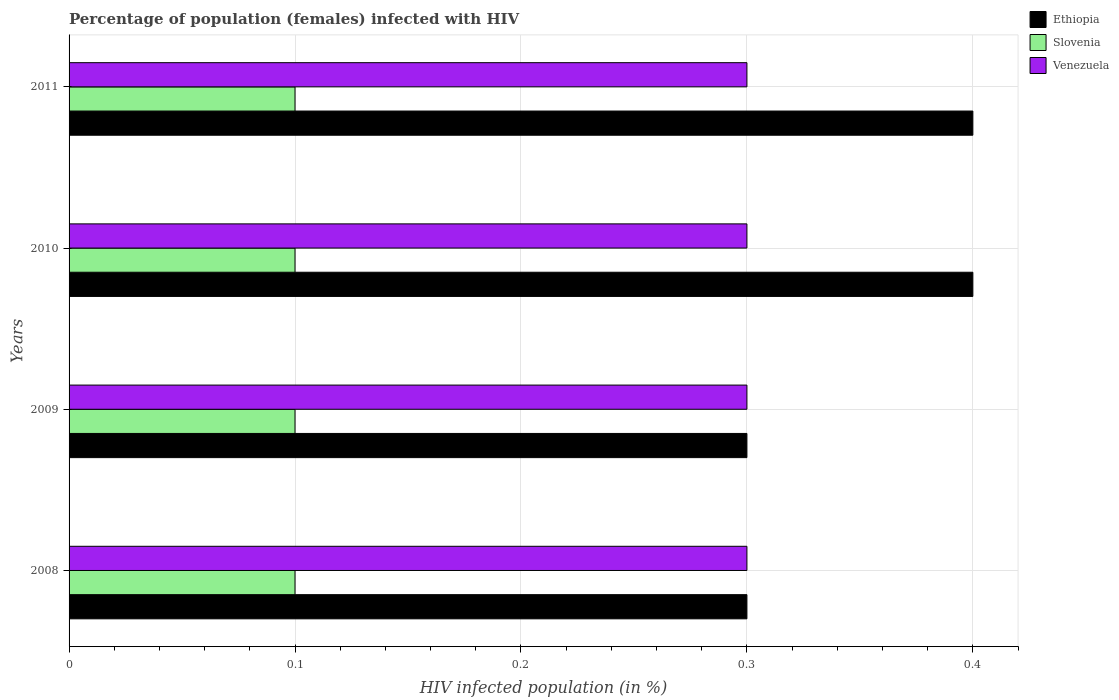How many different coloured bars are there?
Make the answer very short. 3. How many groups of bars are there?
Offer a terse response. 4. Are the number of bars on each tick of the Y-axis equal?
Provide a succinct answer. Yes. How many bars are there on the 1st tick from the bottom?
Your response must be concise. 3. In how many cases, is the number of bars for a given year not equal to the number of legend labels?
Offer a terse response. 0. What is the total percentage of HIV infected female population in Venezuela in the graph?
Offer a very short reply. 1.2. What is the difference between the percentage of HIV infected female population in Ethiopia in 2010 and the percentage of HIV infected female population in Venezuela in 2009?
Make the answer very short. 0.1. In the year 2011, what is the difference between the percentage of HIV infected female population in Ethiopia and percentage of HIV infected female population in Slovenia?
Offer a very short reply. 0.3. What is the difference between the highest and the second highest percentage of HIV infected female population in Venezuela?
Keep it short and to the point. 0. What is the difference between the highest and the lowest percentage of HIV infected female population in Slovenia?
Make the answer very short. 0. In how many years, is the percentage of HIV infected female population in Slovenia greater than the average percentage of HIV infected female population in Slovenia taken over all years?
Your answer should be compact. 0. What does the 3rd bar from the top in 2008 represents?
Your response must be concise. Ethiopia. What does the 2nd bar from the bottom in 2009 represents?
Ensure brevity in your answer.  Slovenia. Are the values on the major ticks of X-axis written in scientific E-notation?
Provide a short and direct response. No. Does the graph contain any zero values?
Give a very brief answer. No. Where does the legend appear in the graph?
Make the answer very short. Top right. How many legend labels are there?
Your answer should be compact. 3. How are the legend labels stacked?
Offer a terse response. Vertical. What is the title of the graph?
Provide a succinct answer. Percentage of population (females) infected with HIV. Does "United States" appear as one of the legend labels in the graph?
Your answer should be compact. No. What is the label or title of the X-axis?
Keep it short and to the point. HIV infected population (in %). What is the HIV infected population (in %) of Ethiopia in 2010?
Your answer should be compact. 0.4. What is the HIV infected population (in %) of Slovenia in 2011?
Make the answer very short. 0.1. Across all years, what is the maximum HIV infected population (in %) in Ethiopia?
Your answer should be compact. 0.4. Across all years, what is the maximum HIV infected population (in %) in Venezuela?
Make the answer very short. 0.3. Across all years, what is the minimum HIV infected population (in %) of Ethiopia?
Provide a short and direct response. 0.3. Across all years, what is the minimum HIV infected population (in %) of Slovenia?
Your answer should be very brief. 0.1. Across all years, what is the minimum HIV infected population (in %) in Venezuela?
Provide a succinct answer. 0.3. What is the total HIV infected population (in %) of Ethiopia in the graph?
Offer a very short reply. 1.4. What is the total HIV infected population (in %) in Slovenia in the graph?
Keep it short and to the point. 0.4. What is the difference between the HIV infected population (in %) of Venezuela in 2008 and that in 2009?
Provide a succinct answer. 0. What is the difference between the HIV infected population (in %) of Ethiopia in 2008 and that in 2010?
Your response must be concise. -0.1. What is the difference between the HIV infected population (in %) of Slovenia in 2008 and that in 2010?
Your answer should be compact. 0. What is the difference between the HIV infected population (in %) of Venezuela in 2008 and that in 2010?
Make the answer very short. 0. What is the difference between the HIV infected population (in %) of Ethiopia in 2008 and that in 2011?
Your answer should be compact. -0.1. What is the difference between the HIV infected population (in %) of Venezuela in 2008 and that in 2011?
Offer a very short reply. 0. What is the difference between the HIV infected population (in %) of Ethiopia in 2009 and that in 2010?
Give a very brief answer. -0.1. What is the difference between the HIV infected population (in %) in Slovenia in 2009 and that in 2010?
Your answer should be compact. 0. What is the difference between the HIV infected population (in %) of Venezuela in 2009 and that in 2010?
Your response must be concise. 0. What is the difference between the HIV infected population (in %) in Venezuela in 2009 and that in 2011?
Your response must be concise. 0. What is the difference between the HIV infected population (in %) in Venezuela in 2010 and that in 2011?
Give a very brief answer. 0. What is the difference between the HIV infected population (in %) of Ethiopia in 2008 and the HIV infected population (in %) of Slovenia in 2009?
Offer a terse response. 0.2. What is the difference between the HIV infected population (in %) of Ethiopia in 2008 and the HIV infected population (in %) of Venezuela in 2009?
Make the answer very short. 0. What is the difference between the HIV infected population (in %) of Slovenia in 2008 and the HIV infected population (in %) of Venezuela in 2009?
Make the answer very short. -0.2. What is the difference between the HIV infected population (in %) in Ethiopia in 2008 and the HIV infected population (in %) in Venezuela in 2010?
Offer a very short reply. 0. What is the difference between the HIV infected population (in %) in Ethiopia in 2008 and the HIV infected population (in %) in Venezuela in 2011?
Ensure brevity in your answer.  0. What is the difference between the HIV infected population (in %) in Ethiopia in 2009 and the HIV infected population (in %) in Slovenia in 2010?
Keep it short and to the point. 0.2. What is the difference between the HIV infected population (in %) of Slovenia in 2009 and the HIV infected population (in %) of Venezuela in 2010?
Your response must be concise. -0.2. What is the difference between the HIV infected population (in %) of Ethiopia in 2009 and the HIV infected population (in %) of Venezuela in 2011?
Your response must be concise. 0. What is the difference between the HIV infected population (in %) in Slovenia in 2009 and the HIV infected population (in %) in Venezuela in 2011?
Give a very brief answer. -0.2. What is the difference between the HIV infected population (in %) in Ethiopia in 2010 and the HIV infected population (in %) in Venezuela in 2011?
Give a very brief answer. 0.1. What is the average HIV infected population (in %) in Ethiopia per year?
Ensure brevity in your answer.  0.35. In the year 2009, what is the difference between the HIV infected population (in %) of Ethiopia and HIV infected population (in %) of Slovenia?
Ensure brevity in your answer.  0.2. In the year 2009, what is the difference between the HIV infected population (in %) of Slovenia and HIV infected population (in %) of Venezuela?
Keep it short and to the point. -0.2. In the year 2010, what is the difference between the HIV infected population (in %) in Ethiopia and HIV infected population (in %) in Slovenia?
Provide a succinct answer. 0.3. In the year 2011, what is the difference between the HIV infected population (in %) in Slovenia and HIV infected population (in %) in Venezuela?
Give a very brief answer. -0.2. What is the ratio of the HIV infected population (in %) in Ethiopia in 2008 to that in 2009?
Your answer should be compact. 1. What is the ratio of the HIV infected population (in %) of Venezuela in 2008 to that in 2009?
Offer a very short reply. 1. What is the ratio of the HIV infected population (in %) in Ethiopia in 2008 to that in 2011?
Ensure brevity in your answer.  0.75. What is the ratio of the HIV infected population (in %) in Ethiopia in 2009 to that in 2010?
Offer a very short reply. 0.75. What is the ratio of the HIV infected population (in %) of Slovenia in 2009 to that in 2010?
Make the answer very short. 1. What is the ratio of the HIV infected population (in %) of Venezuela in 2009 to that in 2010?
Offer a terse response. 1. What is the ratio of the HIV infected population (in %) of Ethiopia in 2010 to that in 2011?
Offer a terse response. 1. What is the difference between the highest and the second highest HIV infected population (in %) in Ethiopia?
Provide a succinct answer. 0. What is the difference between the highest and the second highest HIV infected population (in %) in Slovenia?
Make the answer very short. 0. 